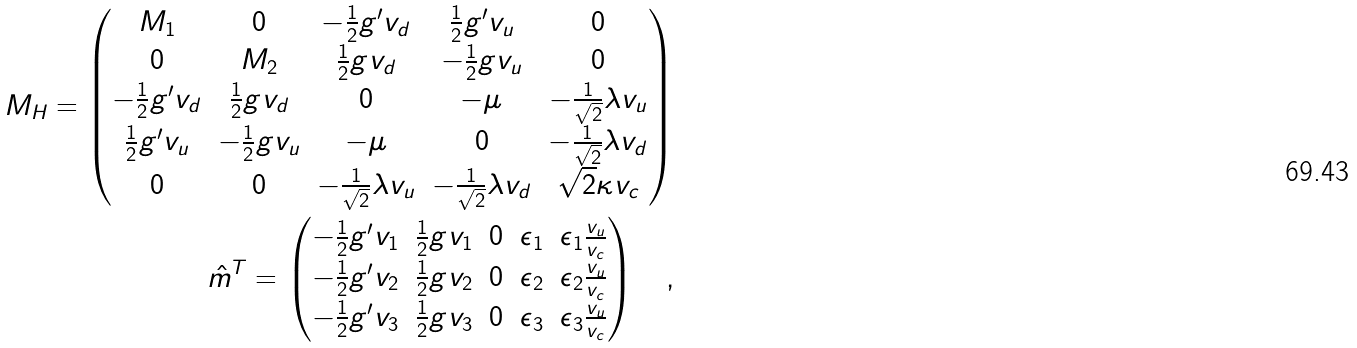<formula> <loc_0><loc_0><loc_500><loc_500>M _ { H } = \begin{pmatrix} M _ { 1 } & 0 & - \frac { 1 } { 2 } g ^ { \prime } v _ { d } & \frac { 1 } { 2 } g ^ { \prime } v _ { u } & 0 \\ 0 & M _ { 2 } & \frac { 1 } { 2 } g v _ { d } & - \frac { 1 } { 2 } g v _ { u } & 0 \\ - \frac { 1 } { 2 } g ^ { \prime } v _ { d } & \frac { 1 } { 2 } g v _ { d } & 0 & - \mu & - \frac { 1 } { \sqrt { 2 } } \lambda v _ { u } \\ \frac { 1 } { 2 } g ^ { \prime } v _ { u } & - \frac { 1 } { 2 } g v _ { u } & - \mu & 0 & - \frac { 1 } { \sqrt { 2 } } \lambda v _ { d } \\ 0 & 0 & - \frac { 1 } { \sqrt { 2 } } \lambda v _ { u } & - \frac { 1 } { \sqrt { 2 } } \lambda v _ { d } & \sqrt { 2 } \kappa v _ { c } \end{pmatrix} \\ \hat { m } ^ { T } = \begin{pmatrix} - \frac { 1 } { 2 } g ^ { \prime } v _ { 1 } & \frac { 1 } { 2 } g v _ { 1 } & 0 & \epsilon _ { 1 } & \epsilon _ { 1 } \frac { v _ { u } } { v _ { c } } \\ - \frac { 1 } { 2 } g ^ { \prime } v _ { 2 } & \frac { 1 } { 2 } g v _ { 2 } & 0 & \epsilon _ { 2 } & \epsilon _ { 2 } \frac { v _ { u } } { v _ { c } } \\ - \frac { 1 } { 2 } g ^ { \prime } v _ { 3 } & \frac { 1 } { 2 } g v _ { 3 } & 0 & \epsilon _ { 3 } & \epsilon _ { 3 } \frac { v _ { u } } { v _ { c } } \end{pmatrix} \quad ,</formula> 